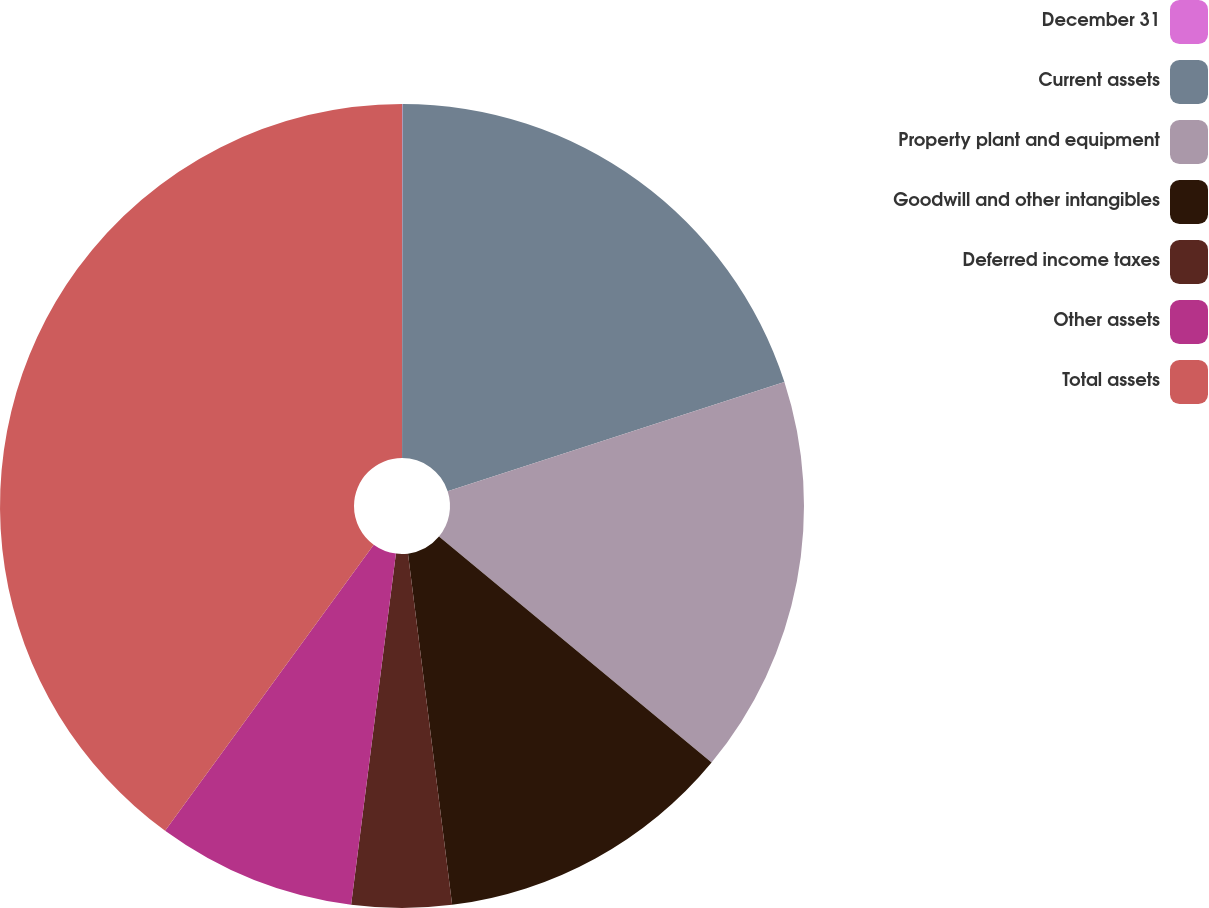Convert chart to OTSL. <chart><loc_0><loc_0><loc_500><loc_500><pie_chart><fcel>December 31<fcel>Current assets<fcel>Property plant and equipment<fcel>Goodwill and other intangibles<fcel>Deferred income taxes<fcel>Other assets<fcel>Total assets<nl><fcel>0.02%<fcel>19.99%<fcel>16.0%<fcel>12.0%<fcel>4.01%<fcel>8.01%<fcel>39.97%<nl></chart> 